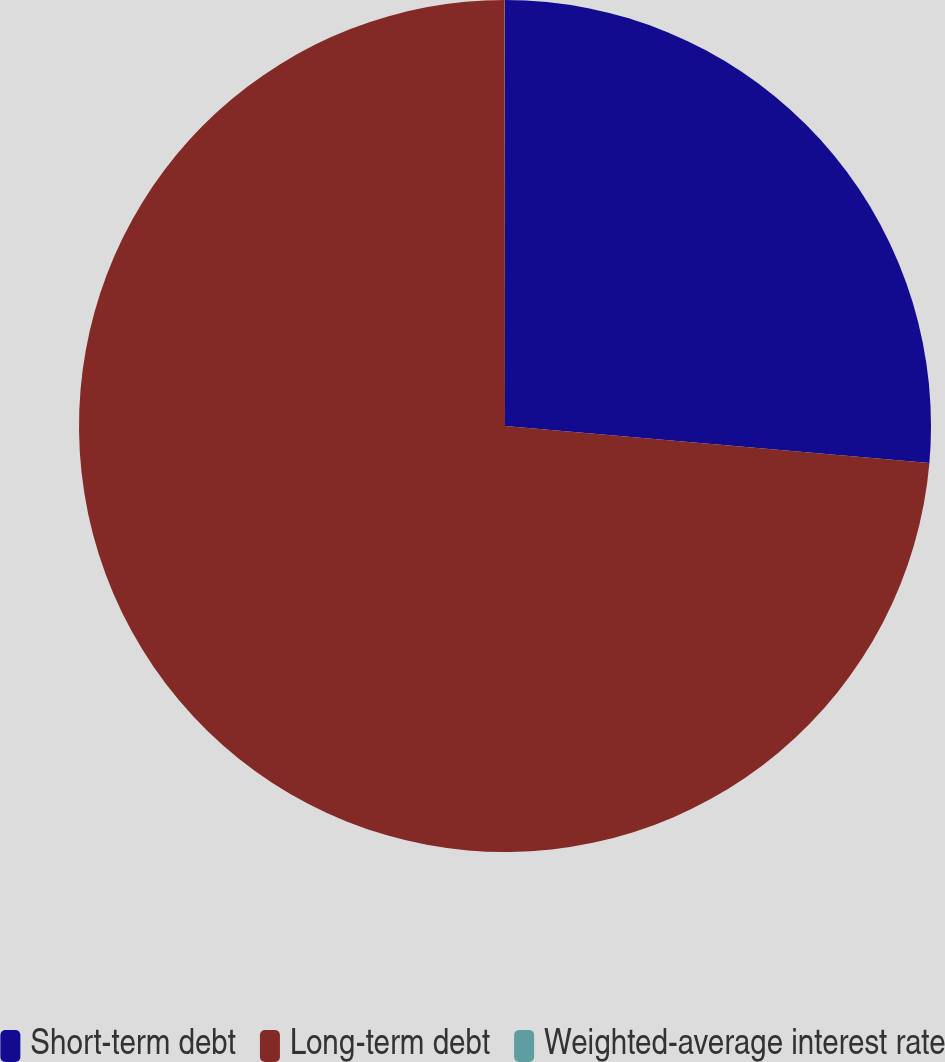Convert chart to OTSL. <chart><loc_0><loc_0><loc_500><loc_500><pie_chart><fcel>Short-term debt<fcel>Long-term debt<fcel>Weighted-average interest rate<nl><fcel>26.38%<fcel>73.61%<fcel>0.01%<nl></chart> 